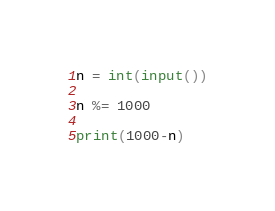<code> <loc_0><loc_0><loc_500><loc_500><_Python_>n = int(input())

n %= 1000

print(1000-n)</code> 